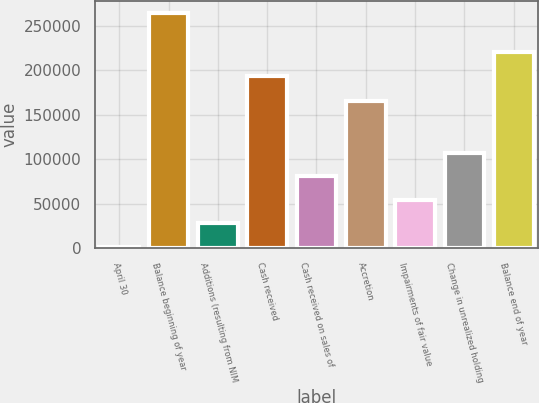<chart> <loc_0><loc_0><loc_500><loc_500><bar_chart><fcel>April 30<fcel>Balance beginning of year<fcel>Additions (resulting from NIM<fcel>Cash received<fcel>Cash received on sales of<fcel>Accretion<fcel>Impairments of fair value<fcel>Change in unrealized holding<fcel>Balance end of year<nl><fcel>2004<fcel>264337<fcel>28237.3<fcel>193606<fcel>80703.9<fcel>165817<fcel>54470.6<fcel>106937<fcel>219839<nl></chart> 